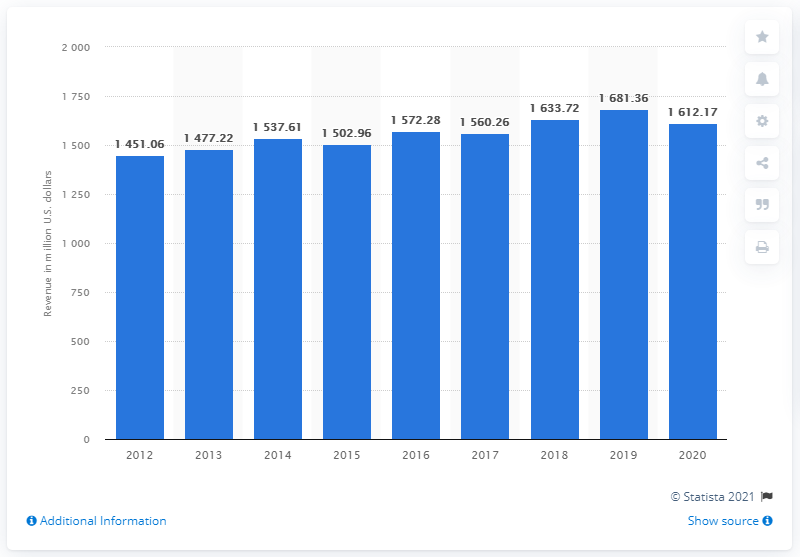Point out several critical features in this image. In 2020, Acushnet's net sales were 1612.17 dollars. 